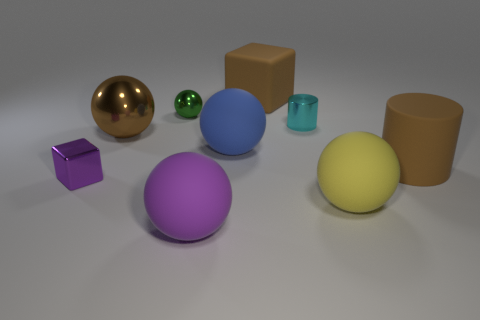How many other things are the same shape as the large blue thing? The large blue object is a sphere. Including this, there are three spherical objects in the image. 